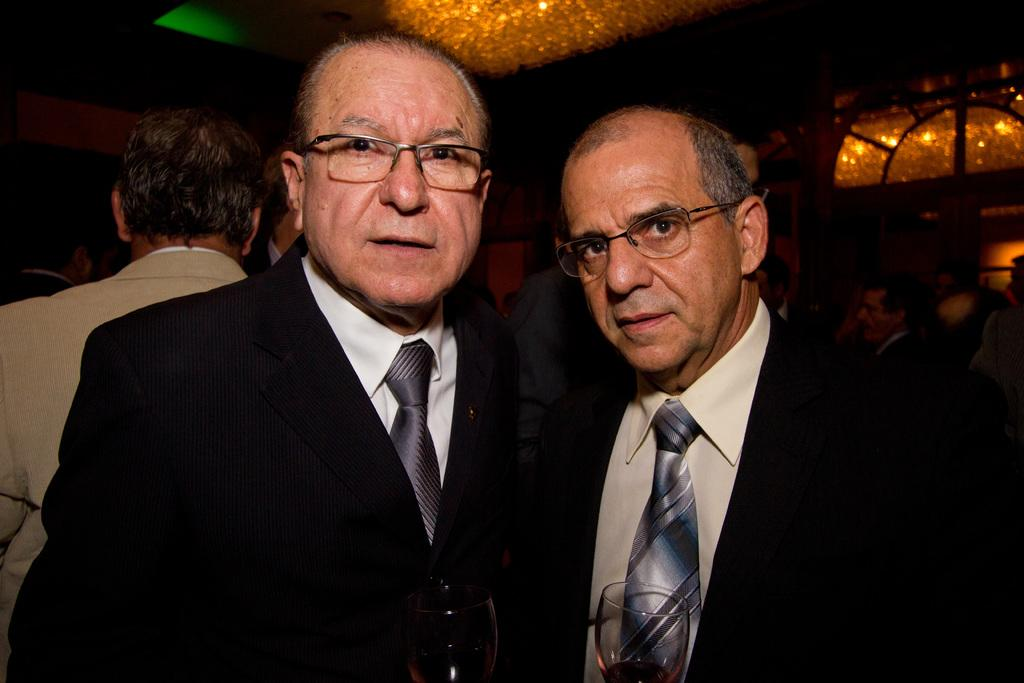How many people are in the image? There are two old men in the image. What are the men wearing? Both men are wearing black suits and ties. What are the men doing in the image? The men are looking into the camera. What color is the glass in the image? The glass in the image is brown. What is the color of the background in the image? The background of the image is dark. Can you see a stream in the background of the image? There is no stream visible in the background of the image. What is the visitor doing in the image? There is no visitor present in the image; it only features the two old men. 